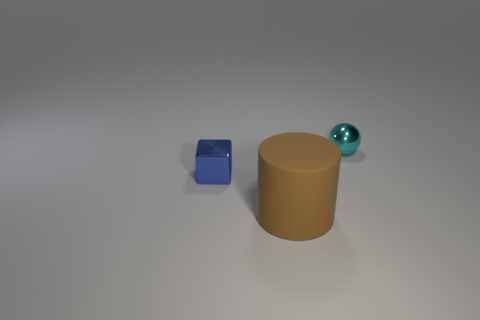Add 2 big rubber objects. How many objects exist? 5 Subtract all cubes. How many objects are left? 2 Add 1 small cyan balls. How many small cyan balls are left? 2 Add 3 big green rubber cubes. How many big green rubber cubes exist? 3 Subtract 0 red cylinders. How many objects are left? 3 Subtract all large matte objects. Subtract all small cyan matte cylinders. How many objects are left? 2 